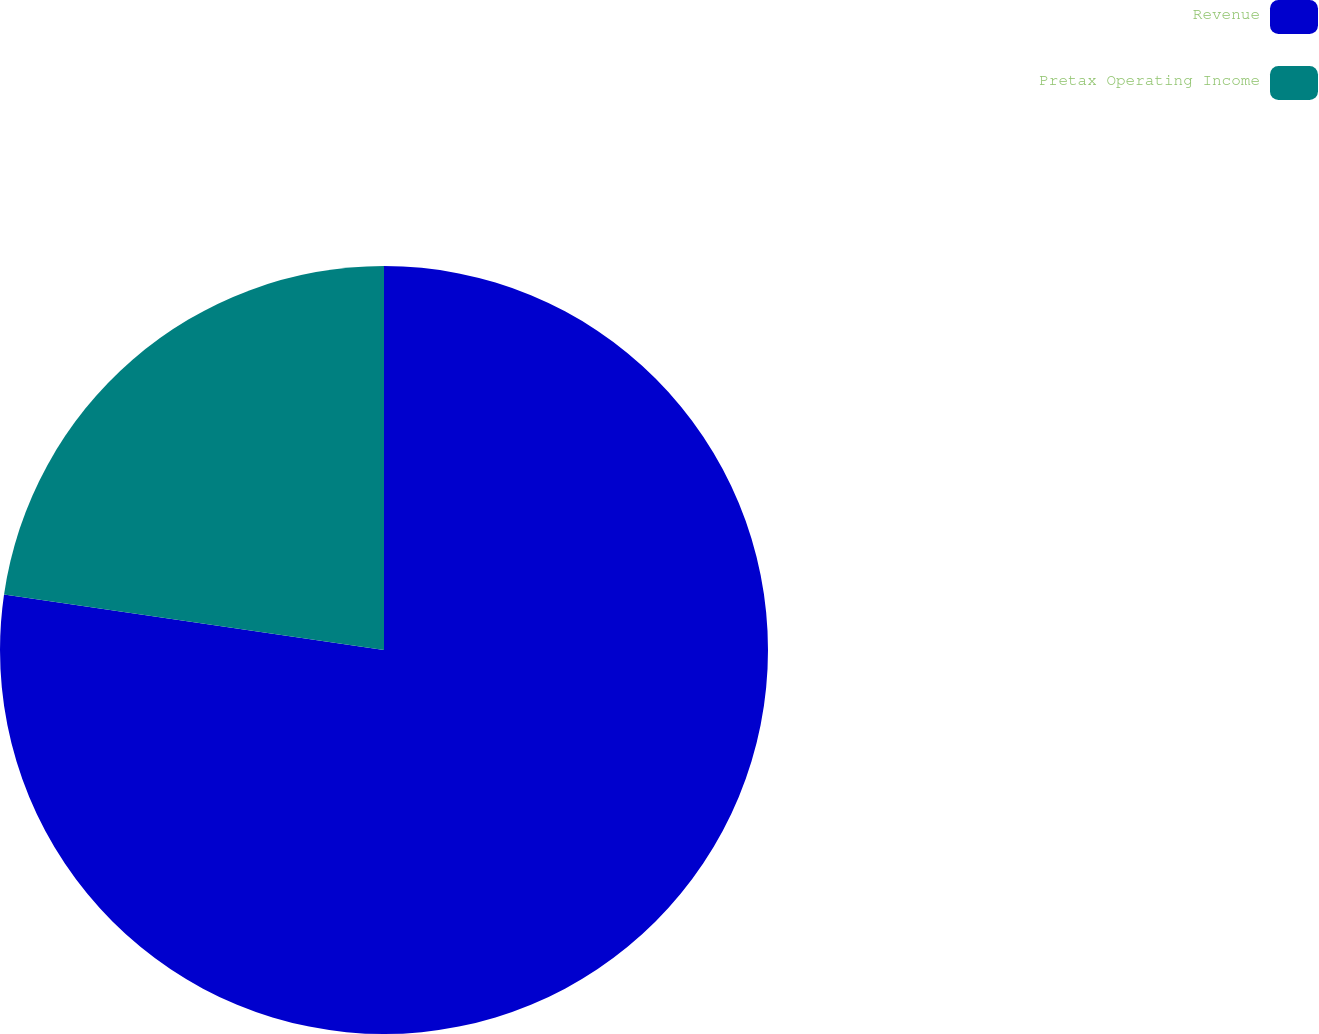Convert chart. <chart><loc_0><loc_0><loc_500><loc_500><pie_chart><fcel>Revenue<fcel>Pretax Operating Income<nl><fcel>77.31%<fcel>22.69%<nl></chart> 